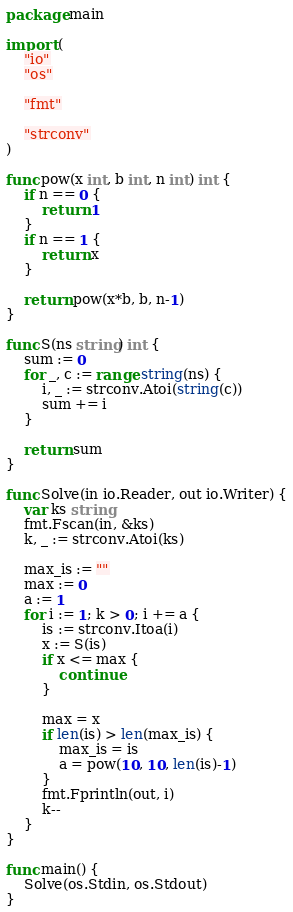Convert code to text. <code><loc_0><loc_0><loc_500><loc_500><_Go_>package main

import (
	"io"
	"os"

	"fmt"

	"strconv"
)

func pow(x int, b int, n int) int {
	if n == 0 {
		return 1
	}
	if n == 1 {
		return x
	}

	return pow(x*b, b, n-1)
}

func S(ns string) int {
	sum := 0
	for _, c := range string(ns) {
		i, _ := strconv.Atoi(string(c))
		sum += i
	}

	return sum
}

func Solve(in io.Reader, out io.Writer) {
	var ks string
	fmt.Fscan(in, &ks)
	k, _ := strconv.Atoi(ks)

	max_is := ""
	max := 0
	a := 1
	for i := 1; k > 0; i += a {
		is := strconv.Itoa(i)
		x := S(is)
		if x <= max {
			continue
		}

		max = x
		if len(is) > len(max_is) {
			max_is = is
			a = pow(10, 10, len(is)-1)
		}
		fmt.Fprintln(out, i)
		k--
	}
}

func main() {
	Solve(os.Stdin, os.Stdout)
}
</code> 